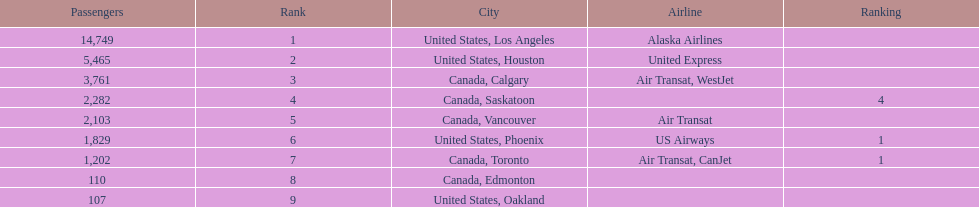Which canadian city had the most passengers traveling from manzanillo international airport in 2013? Calgary. Could you parse the entire table? {'header': ['Passengers', 'Rank', 'City', 'Airline', 'Ranking'], 'rows': [['14,749', '1', 'United States, Los Angeles', 'Alaska Airlines', ''], ['5,465', '2', 'United States, Houston', 'United Express', ''], ['3,761', '3', 'Canada, Calgary', 'Air Transat, WestJet', ''], ['2,282', '4', 'Canada, Saskatoon', '', '4'], ['2,103', '5', 'Canada, Vancouver', 'Air Transat', ''], ['1,829', '6', 'United States, Phoenix', 'US Airways', '1'], ['1,202', '7', 'Canada, Toronto', 'Air Transat, CanJet', '1'], ['110', '8', 'Canada, Edmonton', '', ''], ['107', '9', 'United States, Oakland', '', '']]} 